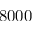Convert formula to latex. <formula><loc_0><loc_0><loc_500><loc_500>8 0 0 0</formula> 